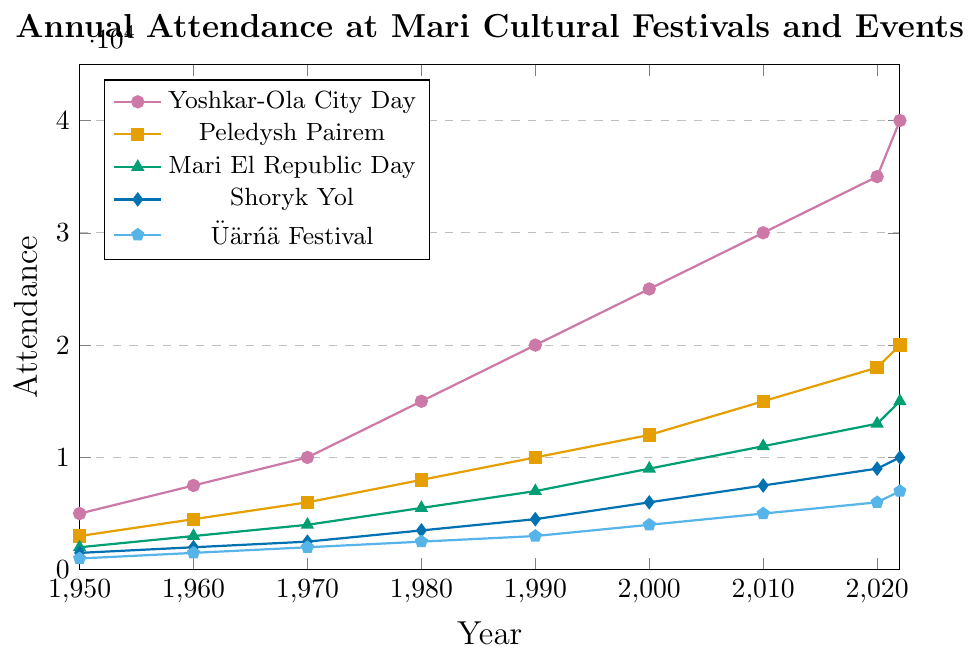Which festival had the highest attendance in 2022? By visually inspecting the graph, we can see that the line representing Yoshkar-Ola City Day reaches the highest point in 2022.
Answer: Yoshkar-Ola City Day What is the difference in attendance between Shoryk Yol and Üärńä Festival in 2020? Looking at the graph, Shoryk Yol has an attendance of 9000, and the Üärńä Festival has 6000 in 2020. The difference is calculated as 9000 - 6000.
Answer: 3000 Which event had the lowest attendance in 1980 and what was the attendance? By inspecting the graph, we see that the Üärńä Festival has the lowest line endpoint in 1980, with an attendance of 2500.
Answer: Üärńä Festival, 2500 By how much did the attendance of Peledysh Pairem grow from 1970 to 1990? The attendance in 1970 for Peledysh Pairem is 6000, and in 1990 it is 10000. The growth is calculated as 10000 - 6000.
Answer: 4000 What was the total attendance for all events combined in 1950? Summing up the values for all events in 1950: 5000 (Yoshkar-Ola City Day) + 3000 (Peledysh Pairem) + 2000 (Mari El Republic Day) + 1500 (Shoryk Yol) + 1000 (Üärńä Festival).
Answer: 12500 Which two festivals had an equal growth rate in attendance from 2000 to 2010? On visual inspection, the growth from 2000 to 2010 for Mari El Republic Day and Üärńä Festival appears equal. Mari El Republic Day grows from 9000 to 11000 (2000), and Üärńä Festival from 4000 to 5000 (1000). The growth rate for both is 2000 and 1000 respectively.
Answer: Mari El Republic Day and Üärńä Festival In which decade did Yoshkar-Ola City Day experience the highest growth in attendance? Comparing the slopes visually, the steepest increase for Yoshkar-Ola City Day appears between 1960 and 1970, increasing from 7500 to 10000 (2500 growth).
Answer: 1960-1970 How many years did it take for Üärńä Festival to double its attendance from 1950? Üärńä Festival's attendance in 1950 is 1000, doubling would mean reaching 2000. This is achieved by 1970. So it took from 1950 to 1970.
Answer: 20 years 